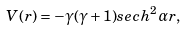<formula> <loc_0><loc_0><loc_500><loc_500>V ( r ) = - { } \gamma ( \gamma + 1 ) s e c h ^ { 2 } { \alpha r } ,</formula> 